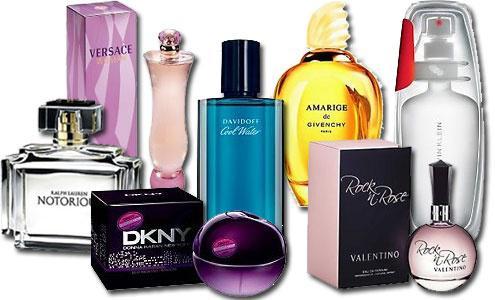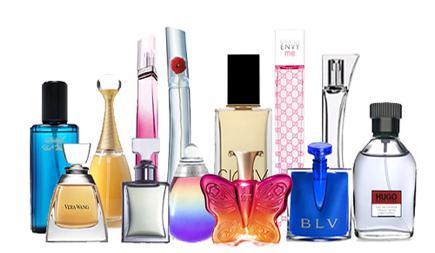The first image is the image on the left, the second image is the image on the right. Assess this claim about the two images: "There is at least one perfume bottle being displayed in the center of the images.". Correct or not? Answer yes or no. Yes. The first image is the image on the left, the second image is the image on the right. Examine the images to the left and right. Is the description "There is a single squared full chanel number 5 perfume bottle in at least one image." accurate? Answer yes or no. No. 